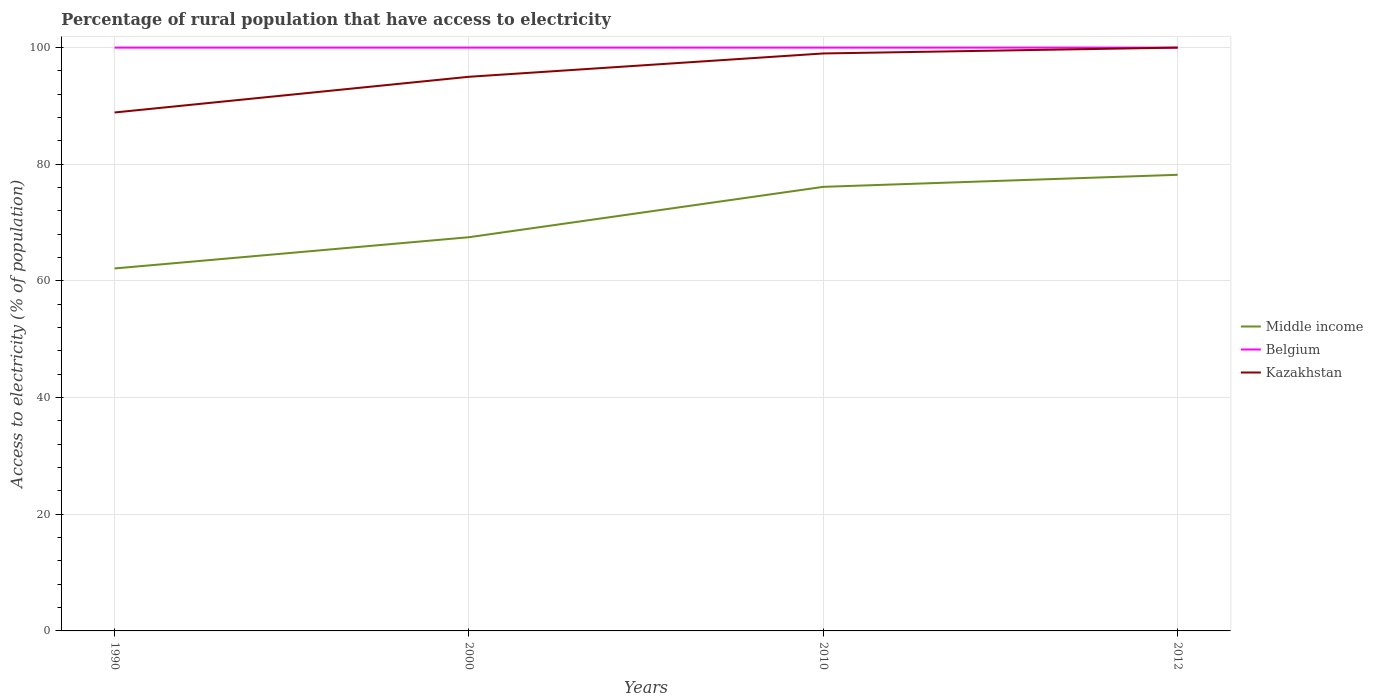Is the number of lines equal to the number of legend labels?
Keep it short and to the point. Yes. Across all years, what is the maximum percentage of rural population that have access to electricity in Kazakhstan?
Provide a short and direct response. 88.88. In which year was the percentage of rural population that have access to electricity in Belgium maximum?
Offer a very short reply. 1990. What is the total percentage of rural population that have access to electricity in Kazakhstan in the graph?
Provide a succinct answer. -10.12. What is the difference between the highest and the second highest percentage of rural population that have access to electricity in Kazakhstan?
Your response must be concise. 11.12. What is the difference between the highest and the lowest percentage of rural population that have access to electricity in Kazakhstan?
Give a very brief answer. 2. How many lines are there?
Provide a short and direct response. 3. How many years are there in the graph?
Give a very brief answer. 4. What is the title of the graph?
Offer a very short reply. Percentage of rural population that have access to electricity. What is the label or title of the X-axis?
Your response must be concise. Years. What is the label or title of the Y-axis?
Provide a short and direct response. Access to electricity (% of population). What is the Access to electricity (% of population) in Middle income in 1990?
Your answer should be very brief. 62.14. What is the Access to electricity (% of population) of Belgium in 1990?
Provide a succinct answer. 100. What is the Access to electricity (% of population) in Kazakhstan in 1990?
Give a very brief answer. 88.88. What is the Access to electricity (% of population) in Middle income in 2000?
Offer a terse response. 67.5. What is the Access to electricity (% of population) of Kazakhstan in 2000?
Keep it short and to the point. 95. What is the Access to electricity (% of population) of Middle income in 2010?
Your answer should be compact. 76.13. What is the Access to electricity (% of population) of Belgium in 2010?
Ensure brevity in your answer.  100. What is the Access to electricity (% of population) in Kazakhstan in 2010?
Offer a very short reply. 99. What is the Access to electricity (% of population) of Middle income in 2012?
Provide a short and direct response. 78.2. What is the Access to electricity (% of population) in Belgium in 2012?
Ensure brevity in your answer.  100. Across all years, what is the maximum Access to electricity (% of population) in Middle income?
Your answer should be compact. 78.2. Across all years, what is the minimum Access to electricity (% of population) of Middle income?
Make the answer very short. 62.14. Across all years, what is the minimum Access to electricity (% of population) of Kazakhstan?
Keep it short and to the point. 88.88. What is the total Access to electricity (% of population) of Middle income in the graph?
Provide a short and direct response. 283.97. What is the total Access to electricity (% of population) in Kazakhstan in the graph?
Provide a short and direct response. 382.88. What is the difference between the Access to electricity (% of population) of Middle income in 1990 and that in 2000?
Provide a succinct answer. -5.36. What is the difference between the Access to electricity (% of population) of Kazakhstan in 1990 and that in 2000?
Make the answer very short. -6.12. What is the difference between the Access to electricity (% of population) in Middle income in 1990 and that in 2010?
Give a very brief answer. -13.99. What is the difference between the Access to electricity (% of population) of Kazakhstan in 1990 and that in 2010?
Your answer should be very brief. -10.12. What is the difference between the Access to electricity (% of population) of Middle income in 1990 and that in 2012?
Provide a succinct answer. -16.06. What is the difference between the Access to electricity (% of population) of Belgium in 1990 and that in 2012?
Provide a short and direct response. 0. What is the difference between the Access to electricity (% of population) in Kazakhstan in 1990 and that in 2012?
Offer a terse response. -11.12. What is the difference between the Access to electricity (% of population) of Middle income in 2000 and that in 2010?
Your answer should be very brief. -8.63. What is the difference between the Access to electricity (% of population) of Belgium in 2000 and that in 2010?
Ensure brevity in your answer.  0. What is the difference between the Access to electricity (% of population) in Kazakhstan in 2000 and that in 2010?
Provide a short and direct response. -4. What is the difference between the Access to electricity (% of population) in Middle income in 2000 and that in 2012?
Your response must be concise. -10.7. What is the difference between the Access to electricity (% of population) of Kazakhstan in 2000 and that in 2012?
Offer a terse response. -5. What is the difference between the Access to electricity (% of population) in Middle income in 2010 and that in 2012?
Provide a succinct answer. -2.07. What is the difference between the Access to electricity (% of population) in Middle income in 1990 and the Access to electricity (% of population) in Belgium in 2000?
Your response must be concise. -37.86. What is the difference between the Access to electricity (% of population) of Middle income in 1990 and the Access to electricity (% of population) of Kazakhstan in 2000?
Offer a terse response. -32.86. What is the difference between the Access to electricity (% of population) in Belgium in 1990 and the Access to electricity (% of population) in Kazakhstan in 2000?
Make the answer very short. 5. What is the difference between the Access to electricity (% of population) of Middle income in 1990 and the Access to electricity (% of population) of Belgium in 2010?
Give a very brief answer. -37.86. What is the difference between the Access to electricity (% of population) in Middle income in 1990 and the Access to electricity (% of population) in Kazakhstan in 2010?
Keep it short and to the point. -36.86. What is the difference between the Access to electricity (% of population) in Belgium in 1990 and the Access to electricity (% of population) in Kazakhstan in 2010?
Provide a short and direct response. 1. What is the difference between the Access to electricity (% of population) in Middle income in 1990 and the Access to electricity (% of population) in Belgium in 2012?
Offer a terse response. -37.86. What is the difference between the Access to electricity (% of population) in Middle income in 1990 and the Access to electricity (% of population) in Kazakhstan in 2012?
Give a very brief answer. -37.86. What is the difference between the Access to electricity (% of population) of Belgium in 1990 and the Access to electricity (% of population) of Kazakhstan in 2012?
Offer a very short reply. 0. What is the difference between the Access to electricity (% of population) in Middle income in 2000 and the Access to electricity (% of population) in Belgium in 2010?
Provide a short and direct response. -32.5. What is the difference between the Access to electricity (% of population) in Middle income in 2000 and the Access to electricity (% of population) in Kazakhstan in 2010?
Offer a very short reply. -31.5. What is the difference between the Access to electricity (% of population) of Middle income in 2000 and the Access to electricity (% of population) of Belgium in 2012?
Keep it short and to the point. -32.5. What is the difference between the Access to electricity (% of population) in Middle income in 2000 and the Access to electricity (% of population) in Kazakhstan in 2012?
Provide a short and direct response. -32.5. What is the difference between the Access to electricity (% of population) in Middle income in 2010 and the Access to electricity (% of population) in Belgium in 2012?
Your response must be concise. -23.87. What is the difference between the Access to electricity (% of population) of Middle income in 2010 and the Access to electricity (% of population) of Kazakhstan in 2012?
Provide a short and direct response. -23.87. What is the average Access to electricity (% of population) of Middle income per year?
Your answer should be very brief. 70.99. What is the average Access to electricity (% of population) in Belgium per year?
Your answer should be very brief. 100. What is the average Access to electricity (% of population) in Kazakhstan per year?
Make the answer very short. 95.72. In the year 1990, what is the difference between the Access to electricity (% of population) in Middle income and Access to electricity (% of population) in Belgium?
Your answer should be very brief. -37.86. In the year 1990, what is the difference between the Access to electricity (% of population) in Middle income and Access to electricity (% of population) in Kazakhstan?
Provide a succinct answer. -26.74. In the year 1990, what is the difference between the Access to electricity (% of population) of Belgium and Access to electricity (% of population) of Kazakhstan?
Keep it short and to the point. 11.12. In the year 2000, what is the difference between the Access to electricity (% of population) of Middle income and Access to electricity (% of population) of Belgium?
Your response must be concise. -32.5. In the year 2000, what is the difference between the Access to electricity (% of population) of Middle income and Access to electricity (% of population) of Kazakhstan?
Offer a terse response. -27.5. In the year 2010, what is the difference between the Access to electricity (% of population) in Middle income and Access to electricity (% of population) in Belgium?
Give a very brief answer. -23.87. In the year 2010, what is the difference between the Access to electricity (% of population) of Middle income and Access to electricity (% of population) of Kazakhstan?
Your answer should be very brief. -22.87. In the year 2012, what is the difference between the Access to electricity (% of population) in Middle income and Access to electricity (% of population) in Belgium?
Your answer should be compact. -21.8. In the year 2012, what is the difference between the Access to electricity (% of population) in Middle income and Access to electricity (% of population) in Kazakhstan?
Your response must be concise. -21.8. What is the ratio of the Access to electricity (% of population) of Middle income in 1990 to that in 2000?
Provide a short and direct response. 0.92. What is the ratio of the Access to electricity (% of population) in Belgium in 1990 to that in 2000?
Offer a terse response. 1. What is the ratio of the Access to electricity (% of population) of Kazakhstan in 1990 to that in 2000?
Your answer should be very brief. 0.94. What is the ratio of the Access to electricity (% of population) of Middle income in 1990 to that in 2010?
Your answer should be compact. 0.82. What is the ratio of the Access to electricity (% of population) of Belgium in 1990 to that in 2010?
Provide a short and direct response. 1. What is the ratio of the Access to electricity (% of population) in Kazakhstan in 1990 to that in 2010?
Offer a very short reply. 0.9. What is the ratio of the Access to electricity (% of population) of Middle income in 1990 to that in 2012?
Keep it short and to the point. 0.79. What is the ratio of the Access to electricity (% of population) of Belgium in 1990 to that in 2012?
Your answer should be very brief. 1. What is the ratio of the Access to electricity (% of population) of Kazakhstan in 1990 to that in 2012?
Give a very brief answer. 0.89. What is the ratio of the Access to electricity (% of population) in Middle income in 2000 to that in 2010?
Offer a terse response. 0.89. What is the ratio of the Access to electricity (% of population) of Belgium in 2000 to that in 2010?
Your response must be concise. 1. What is the ratio of the Access to electricity (% of population) of Kazakhstan in 2000 to that in 2010?
Offer a terse response. 0.96. What is the ratio of the Access to electricity (% of population) in Middle income in 2000 to that in 2012?
Your answer should be compact. 0.86. What is the ratio of the Access to electricity (% of population) in Kazakhstan in 2000 to that in 2012?
Give a very brief answer. 0.95. What is the ratio of the Access to electricity (% of population) of Middle income in 2010 to that in 2012?
Your answer should be very brief. 0.97. What is the difference between the highest and the second highest Access to electricity (% of population) in Middle income?
Your answer should be very brief. 2.07. What is the difference between the highest and the second highest Access to electricity (% of population) of Kazakhstan?
Offer a terse response. 1. What is the difference between the highest and the lowest Access to electricity (% of population) of Middle income?
Offer a terse response. 16.06. What is the difference between the highest and the lowest Access to electricity (% of population) of Kazakhstan?
Your response must be concise. 11.12. 